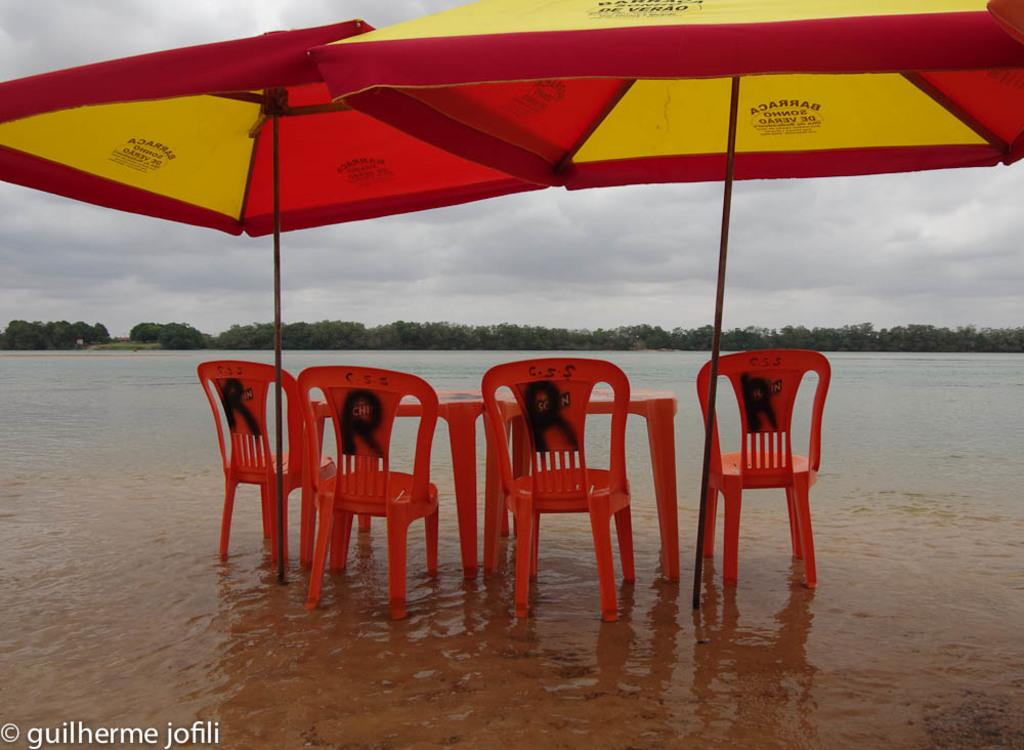What type of temporary shelters can be seen in the image? There are tents in the image. What type of furniture is present in the image? There are chairs and tables in the image. What type of natural vegetation is visible in the image? There are trees in the image. What type of natural body is visible in the image? There is water visible in the image. What is visible in the background of the image? The sky is visible in the background of the image. What type of atmospheric phenomena can be seen in the sky? Clouds are present in the sky. What type of jam is being spread on the chairs in the image? There is no jam present in the image, and the chairs are not being used for spreading jam. What type of punishment is being administered to the trees in the image? There is no punishment being administered to the trees in the image; they are simply standing in their natural state. 